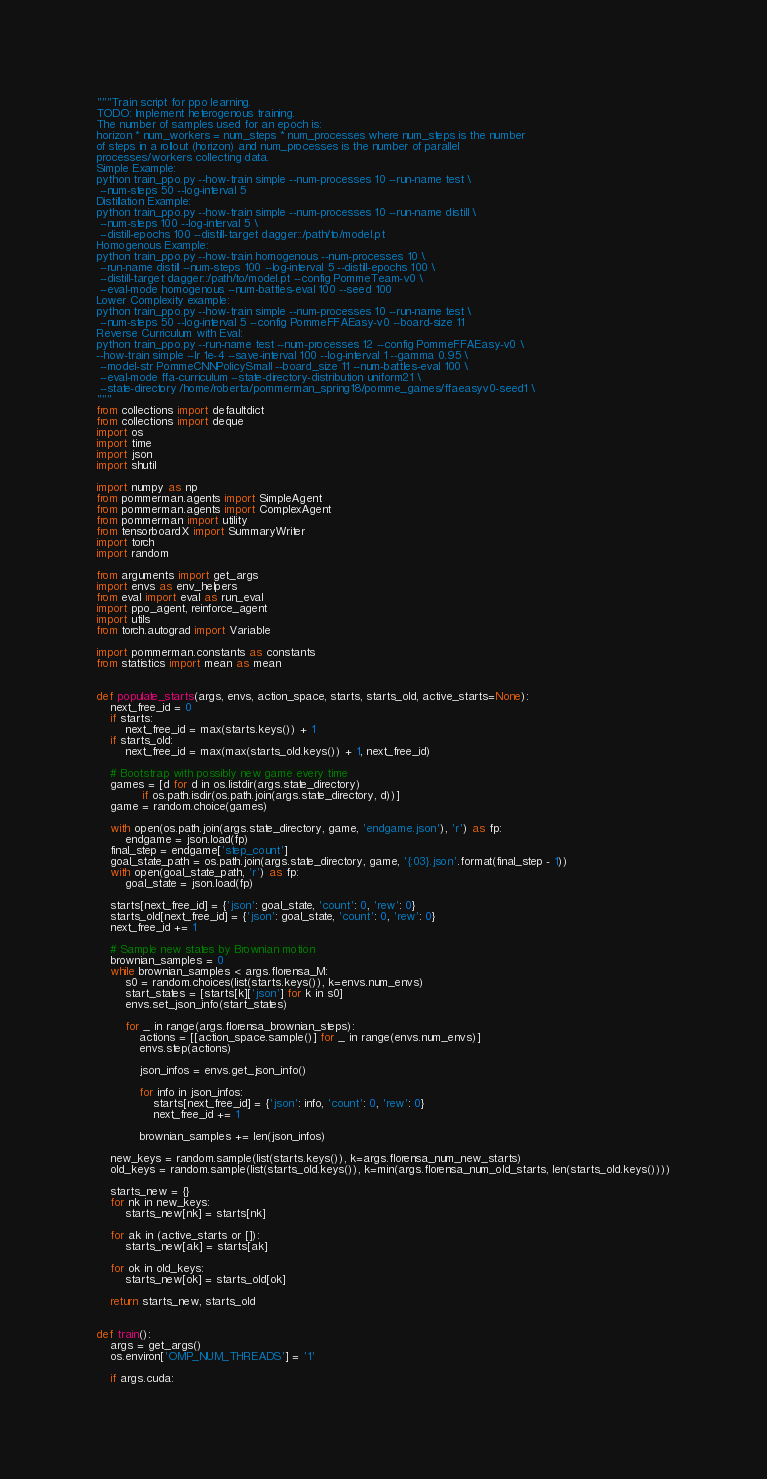<code> <loc_0><loc_0><loc_500><loc_500><_Python_>"""Train script for ppo learning.
TODO: Implement heterogenous training.
The number of samples used for an epoch is:
horizon * num_workers = num_steps * num_processes where num_steps is the number
of steps in a rollout (horizon) and num_processes is the number of parallel
processes/workers collecting data.
Simple Example:
python train_ppo.py --how-train simple --num-processes 10 --run-name test \
 --num-steps 50 --log-interval 5
Distillation Example:
python train_ppo.py --how-train simple --num-processes 10 --run-name distill \
 --num-steps 100 --log-interval 5 \
 --distill-epochs 100 --distill-target dagger::/path/to/model.pt
Homogenous Example:
python train_ppo.py --how-train homogenous --num-processes 10 \
 --run-name distill --num-steps 100 --log-interval 5 --distill-epochs 100 \
 --distill-target dagger::/path/to/model.pt --config PommeTeam-v0 \
 --eval-mode homogenous --num-battles-eval 100 --seed 100
Lower Complexity example:
python train_ppo.py --how-train simple --num-processes 10 --run-name test \
 --num-steps 50 --log-interval 5 --config PommeFFAEasy-v0 --board-size 11
Reverse Curriculum with Eval:
python train_ppo.py --run-name test --num-processes 12 --config PommeFFAEasy-v0 \
--how-train simple --lr 1e-4 --save-interval 100 --log-interval 1 --gamma 0.95 \
 --model-str PommeCNNPolicySmall --board_size 11 --num-battles-eval 100 \
 --eval-mode ffa-curriculum --state-directory-distribution uniform21 \
 --state-directory /home/roberta/pommerman_spring18/pomme_games/ffaeasyv0-seed1 \
"""
from collections import defaultdict
from collections import deque
import os
import time
import json
import shutil

import numpy as np
from pommerman.agents import SimpleAgent
from pommerman.agents import ComplexAgent
from pommerman import utility
from tensorboardX import SummaryWriter
import torch
import random

from arguments import get_args
import envs as env_helpers
from eval import eval as run_eval
import ppo_agent, reinforce_agent
import utils
from torch.autograd import Variable

import pommerman.constants as constants
from statistics import mean as mean


def populate_starts(args, envs, action_space, starts, starts_old, active_starts=None):
    next_free_id = 0
    if starts:
        next_free_id = max(starts.keys()) + 1
    if starts_old:
        next_free_id = max(max(starts_old.keys()) + 1, next_free_id)

    # Bootstrap with possibly new game every time
    games = [d for d in os.listdir(args.state_directory)
             if os.path.isdir(os.path.join(args.state_directory, d))]
    game = random.choice(games)

    with open(os.path.join(args.state_directory, game, 'endgame.json'), 'r') as fp:
        endgame = json.load(fp)
    final_step = endgame['step_count']
    goal_state_path = os.path.join(args.state_directory, game, '{:03}.json'.format(final_step - 1))
    with open(goal_state_path, 'r') as fp:
        goal_state = json.load(fp)

    starts[next_free_id] = {'json': goal_state, 'count': 0, 'rew': 0}
    starts_old[next_free_id] = {'json': goal_state, 'count': 0, 'rew': 0}
    next_free_id += 1

    # Sample new states by Brownian motion
    brownian_samples = 0
    while brownian_samples < args.florensa_M:
        s0 = random.choices(list(starts.keys()), k=envs.num_envs)
        start_states = [starts[k]['json'] for k in s0]
        envs.set_json_info(start_states)

        for _ in range(args.florensa_brownian_steps):
            actions = [[action_space.sample()] for _ in range(envs.num_envs)]
            envs.step(actions)

            json_infos = envs.get_json_info()

            for info in json_infos:
                starts[next_free_id] = {'json': info, 'count': 0, 'rew': 0}
                next_free_id += 1

            brownian_samples += len(json_infos)

    new_keys = random.sample(list(starts.keys()), k=args.florensa_num_new_starts)
    old_keys = random.sample(list(starts_old.keys()), k=min(args.florensa_num_old_starts, len(starts_old.keys())))

    starts_new = {}
    for nk in new_keys:
        starts_new[nk] = starts[nk]

    for ak in (active_starts or []):
        starts_new[ak] = starts[ak]

    for ok in old_keys:
        starts_new[ok] = starts_old[ok]

    return starts_new, starts_old


def train():
    args = get_args()
    os.environ['OMP_NUM_THREADS'] = '1'

    if args.cuda:</code> 